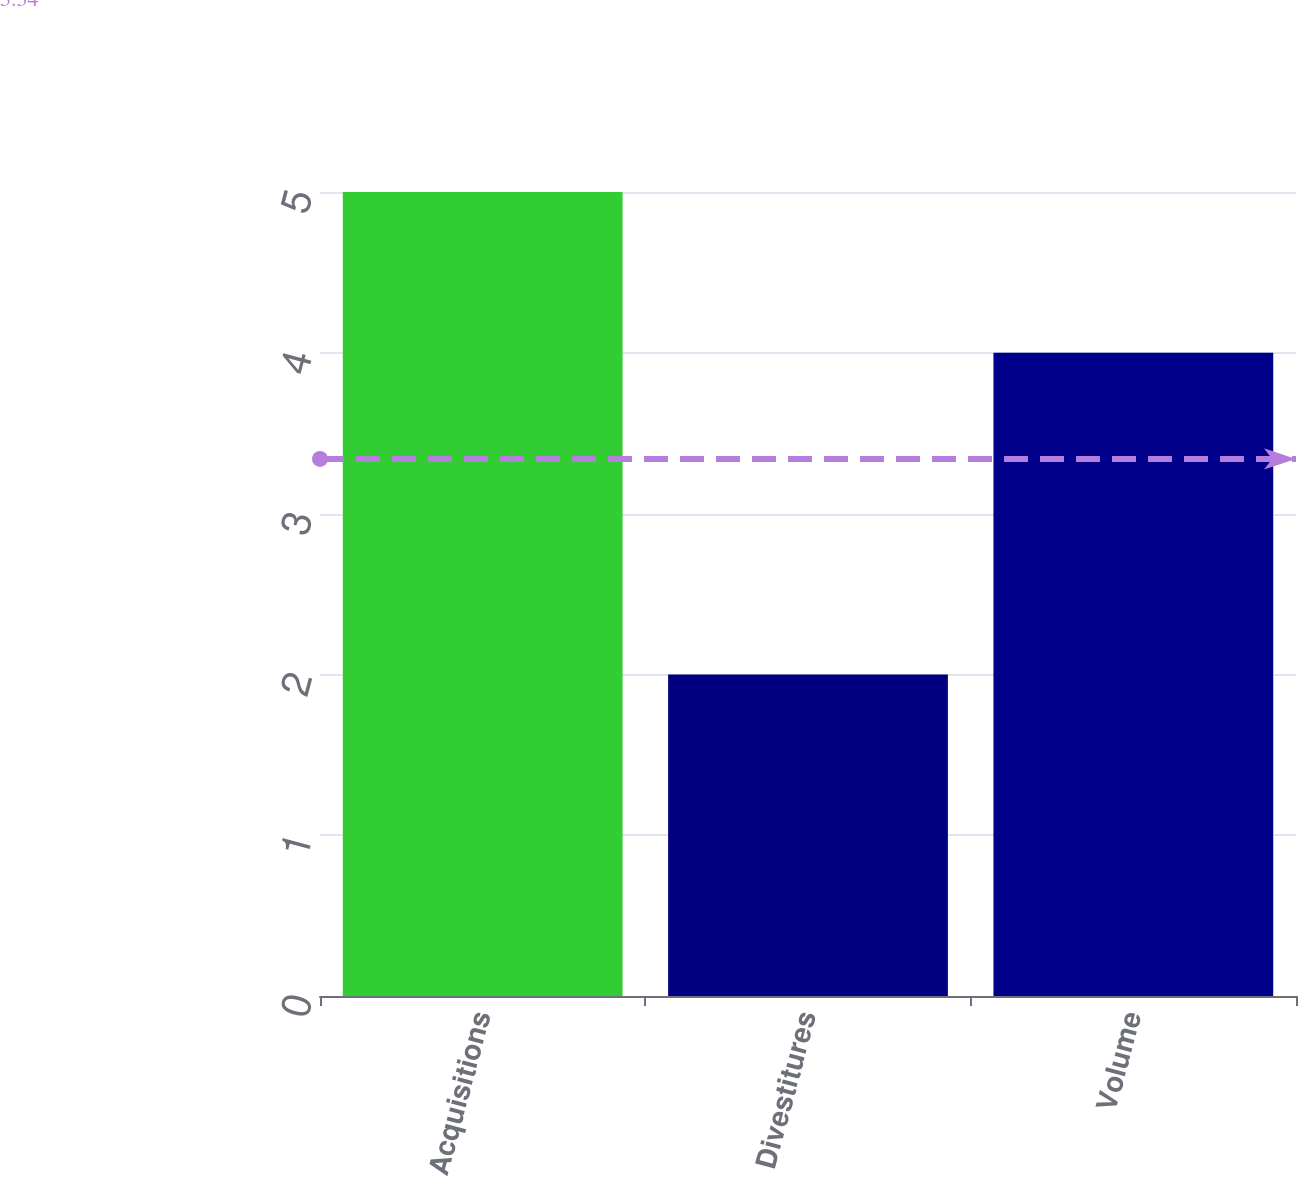Convert chart. <chart><loc_0><loc_0><loc_500><loc_500><bar_chart><fcel>Acquisitions<fcel>Divestitures<fcel>Volume<nl><fcel>5<fcel>2<fcel>4<nl></chart> 